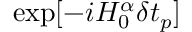Convert formula to latex. <formula><loc_0><loc_0><loc_500><loc_500>\exp [ - i H _ { 0 } ^ { \alpha } \delta t _ { p } ]</formula> 